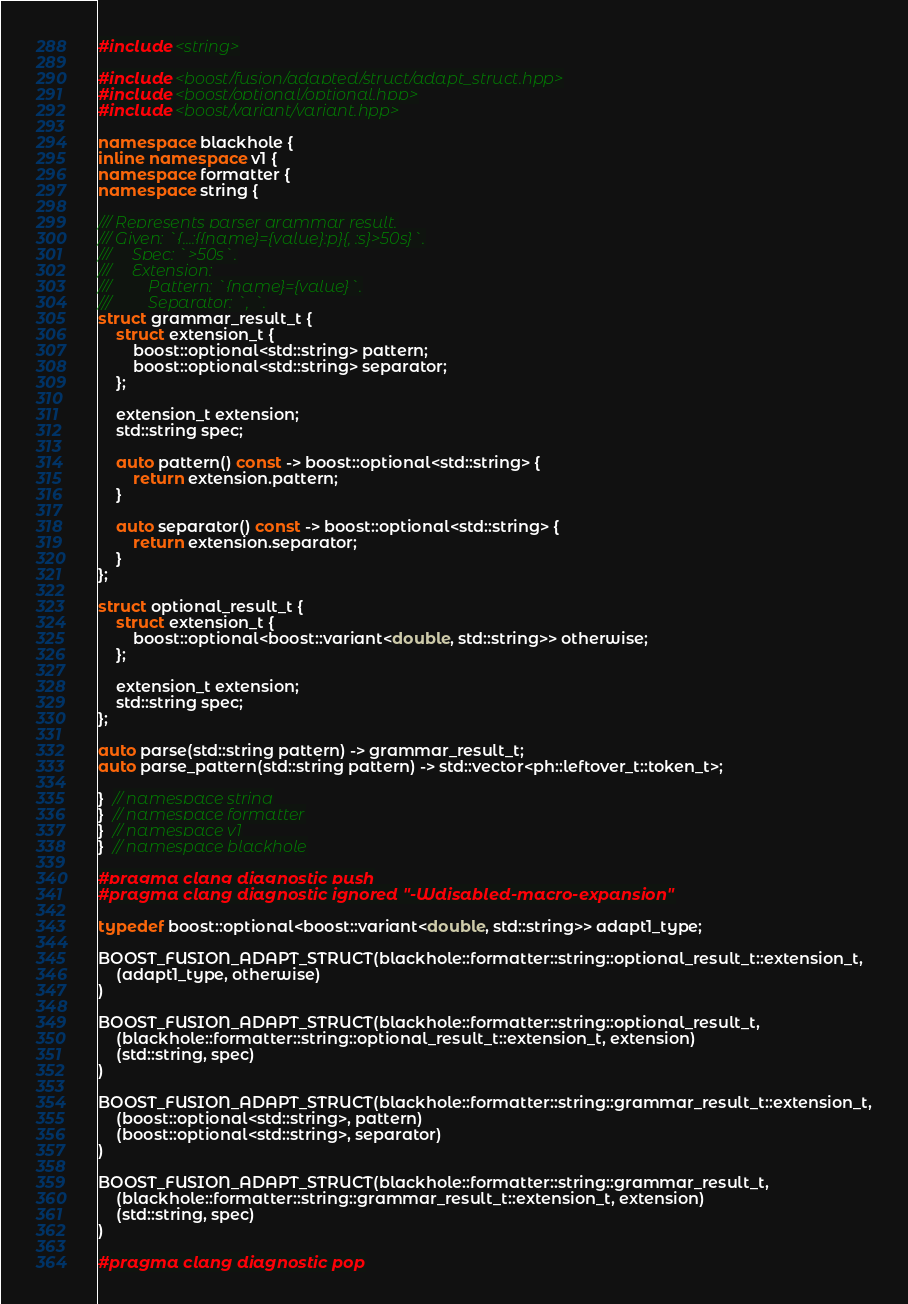<code> <loc_0><loc_0><loc_500><loc_500><_C++_>#include <string>

#include <boost/fusion/adapted/struct/adapt_struct.hpp>
#include <boost/optional/optional.hpp>
#include <boost/variant/variant.hpp>

namespace blackhole {
inline namespace v1 {
namespace formatter {
namespace string {

/// Represents parser grammar result.
/// Given: `{...:{{name}={value}:p}{, :s}>50s}`.
///     Spec: `>50s`.
///     Extension:
///         Pattern: `{name}={value}`.
///         Separator: `, `.
struct grammar_result_t {
    struct extension_t {
        boost::optional<std::string> pattern;
        boost::optional<std::string> separator;
    };

    extension_t extension;
    std::string spec;

    auto pattern() const -> boost::optional<std::string> {
        return extension.pattern;
    }

    auto separator() const -> boost::optional<std::string> {
        return extension.separator;
    }
};

struct optional_result_t {
    struct extension_t {
        boost::optional<boost::variant<double, std::string>> otherwise;
    };

    extension_t extension;
    std::string spec;
};

auto parse(std::string pattern) -> grammar_result_t;
auto parse_pattern(std::string pattern) -> std::vector<ph::leftover_t::token_t>;

}  // namespace string
}  // namespace formatter
}  // namespace v1
}  // namespace blackhole

#pragma clang diagnostic push
#pragma clang diagnostic ignored "-Wdisabled-macro-expansion"

typedef boost::optional<boost::variant<double, std::string>> adapt1_type;

BOOST_FUSION_ADAPT_STRUCT(blackhole::formatter::string::optional_result_t::extension_t,
    (adapt1_type, otherwise)
)

BOOST_FUSION_ADAPT_STRUCT(blackhole::formatter::string::optional_result_t,
    (blackhole::formatter::string::optional_result_t::extension_t, extension)
    (std::string, spec)
)

BOOST_FUSION_ADAPT_STRUCT(blackhole::formatter::string::grammar_result_t::extension_t,
    (boost::optional<std::string>, pattern)
    (boost::optional<std::string>, separator)
)

BOOST_FUSION_ADAPT_STRUCT(blackhole::formatter::string::grammar_result_t,
    (blackhole::formatter::string::grammar_result_t::extension_t, extension)
    (std::string, spec)
)

#pragma clang diagnostic pop
</code> 